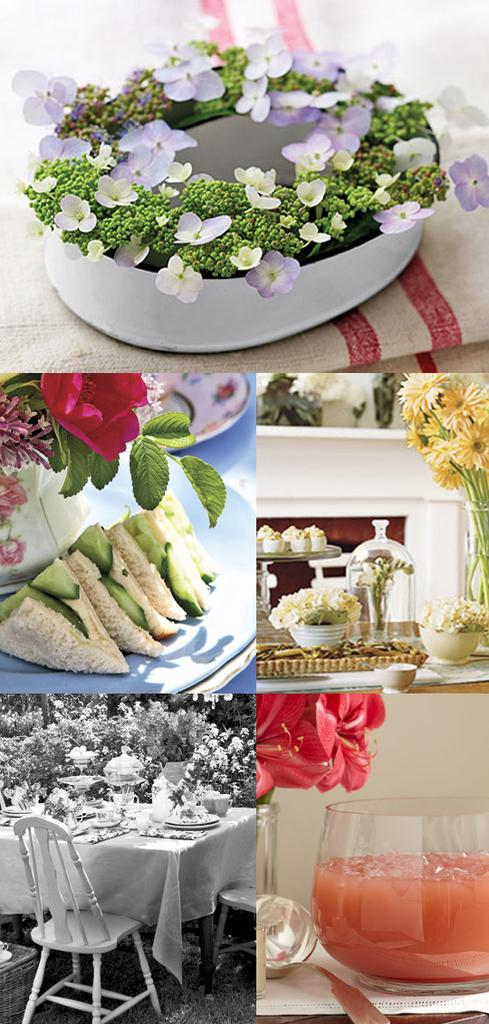What type of plant can be seen in the image? There is a flower in the image. What else is present in the image besides the flower? There are food items, a chair, a table, and a glass in the image. What might be used for holding or serving a beverage in the image? The glass in the image can be used for holding or serving a beverage. What is the primary piece of furniture in the image? The table is the primary piece of furniture in the image. What type of leaf can be seen on the clover in the image? There is no clover present in the image, so it is not possible to determine the type of leaf on a clover. 